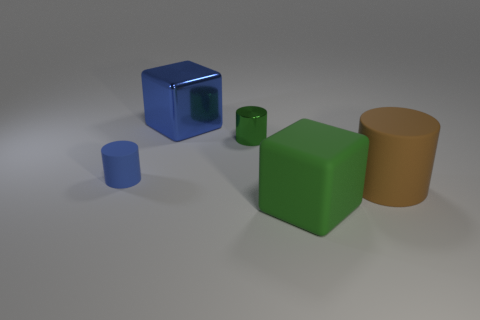Add 2 brown rubber objects. How many objects exist? 7 Subtract all cylinders. How many objects are left? 2 Add 4 big blue cubes. How many big blue cubes are left? 5 Add 3 small balls. How many small balls exist? 3 Subtract 0 blue balls. How many objects are left? 5 Subtract all tiny green cylinders. Subtract all big gray matte objects. How many objects are left? 4 